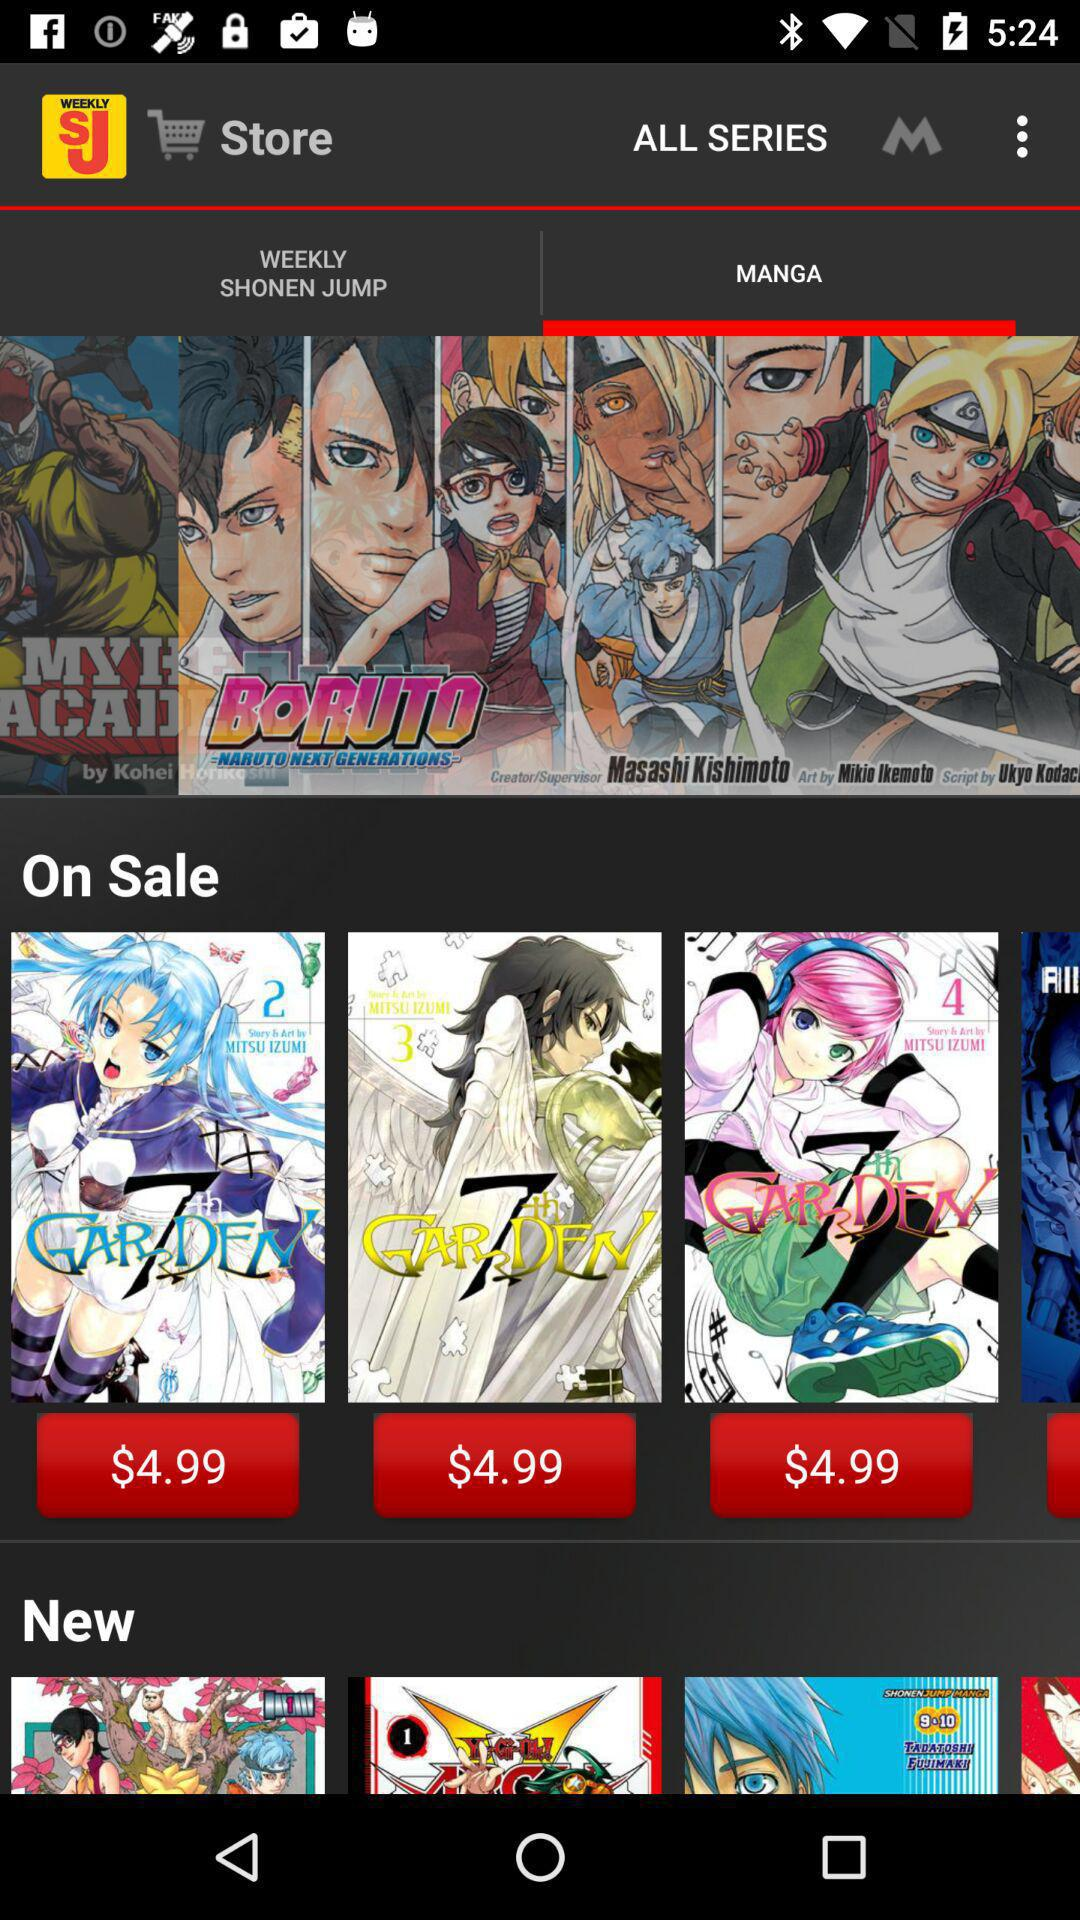Which tab is selected? The selected tab is "WEEKLY SHONEN JUMP". 